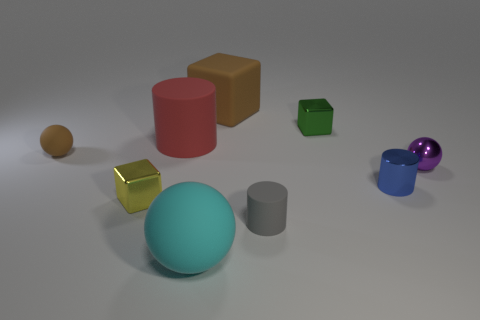Add 1 red blocks. How many objects exist? 10 Subtract all tiny spheres. How many spheres are left? 1 Subtract 1 cubes. How many cubes are left? 2 Subtract all green blocks. How many blocks are left? 2 Subtract all cubes. How many objects are left? 6 Subtract all blue cylinders. Subtract all gray balls. How many cylinders are left? 2 Subtract all red spheres. How many green blocks are left? 1 Subtract all small purple things. Subtract all large red objects. How many objects are left? 7 Add 3 large matte cylinders. How many large matte cylinders are left? 4 Add 8 red matte cylinders. How many red matte cylinders exist? 9 